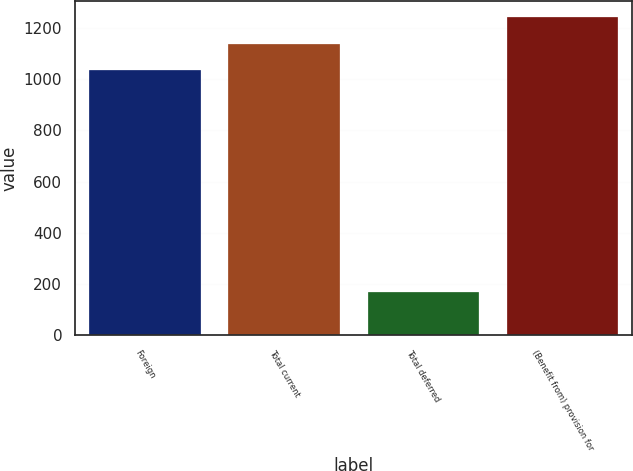Convert chart. <chart><loc_0><loc_0><loc_500><loc_500><bar_chart><fcel>Foreign<fcel>Total current<fcel>Total deferred<fcel>(Benefit from) provision for<nl><fcel>1035<fcel>1138.5<fcel>166<fcel>1242<nl></chart> 